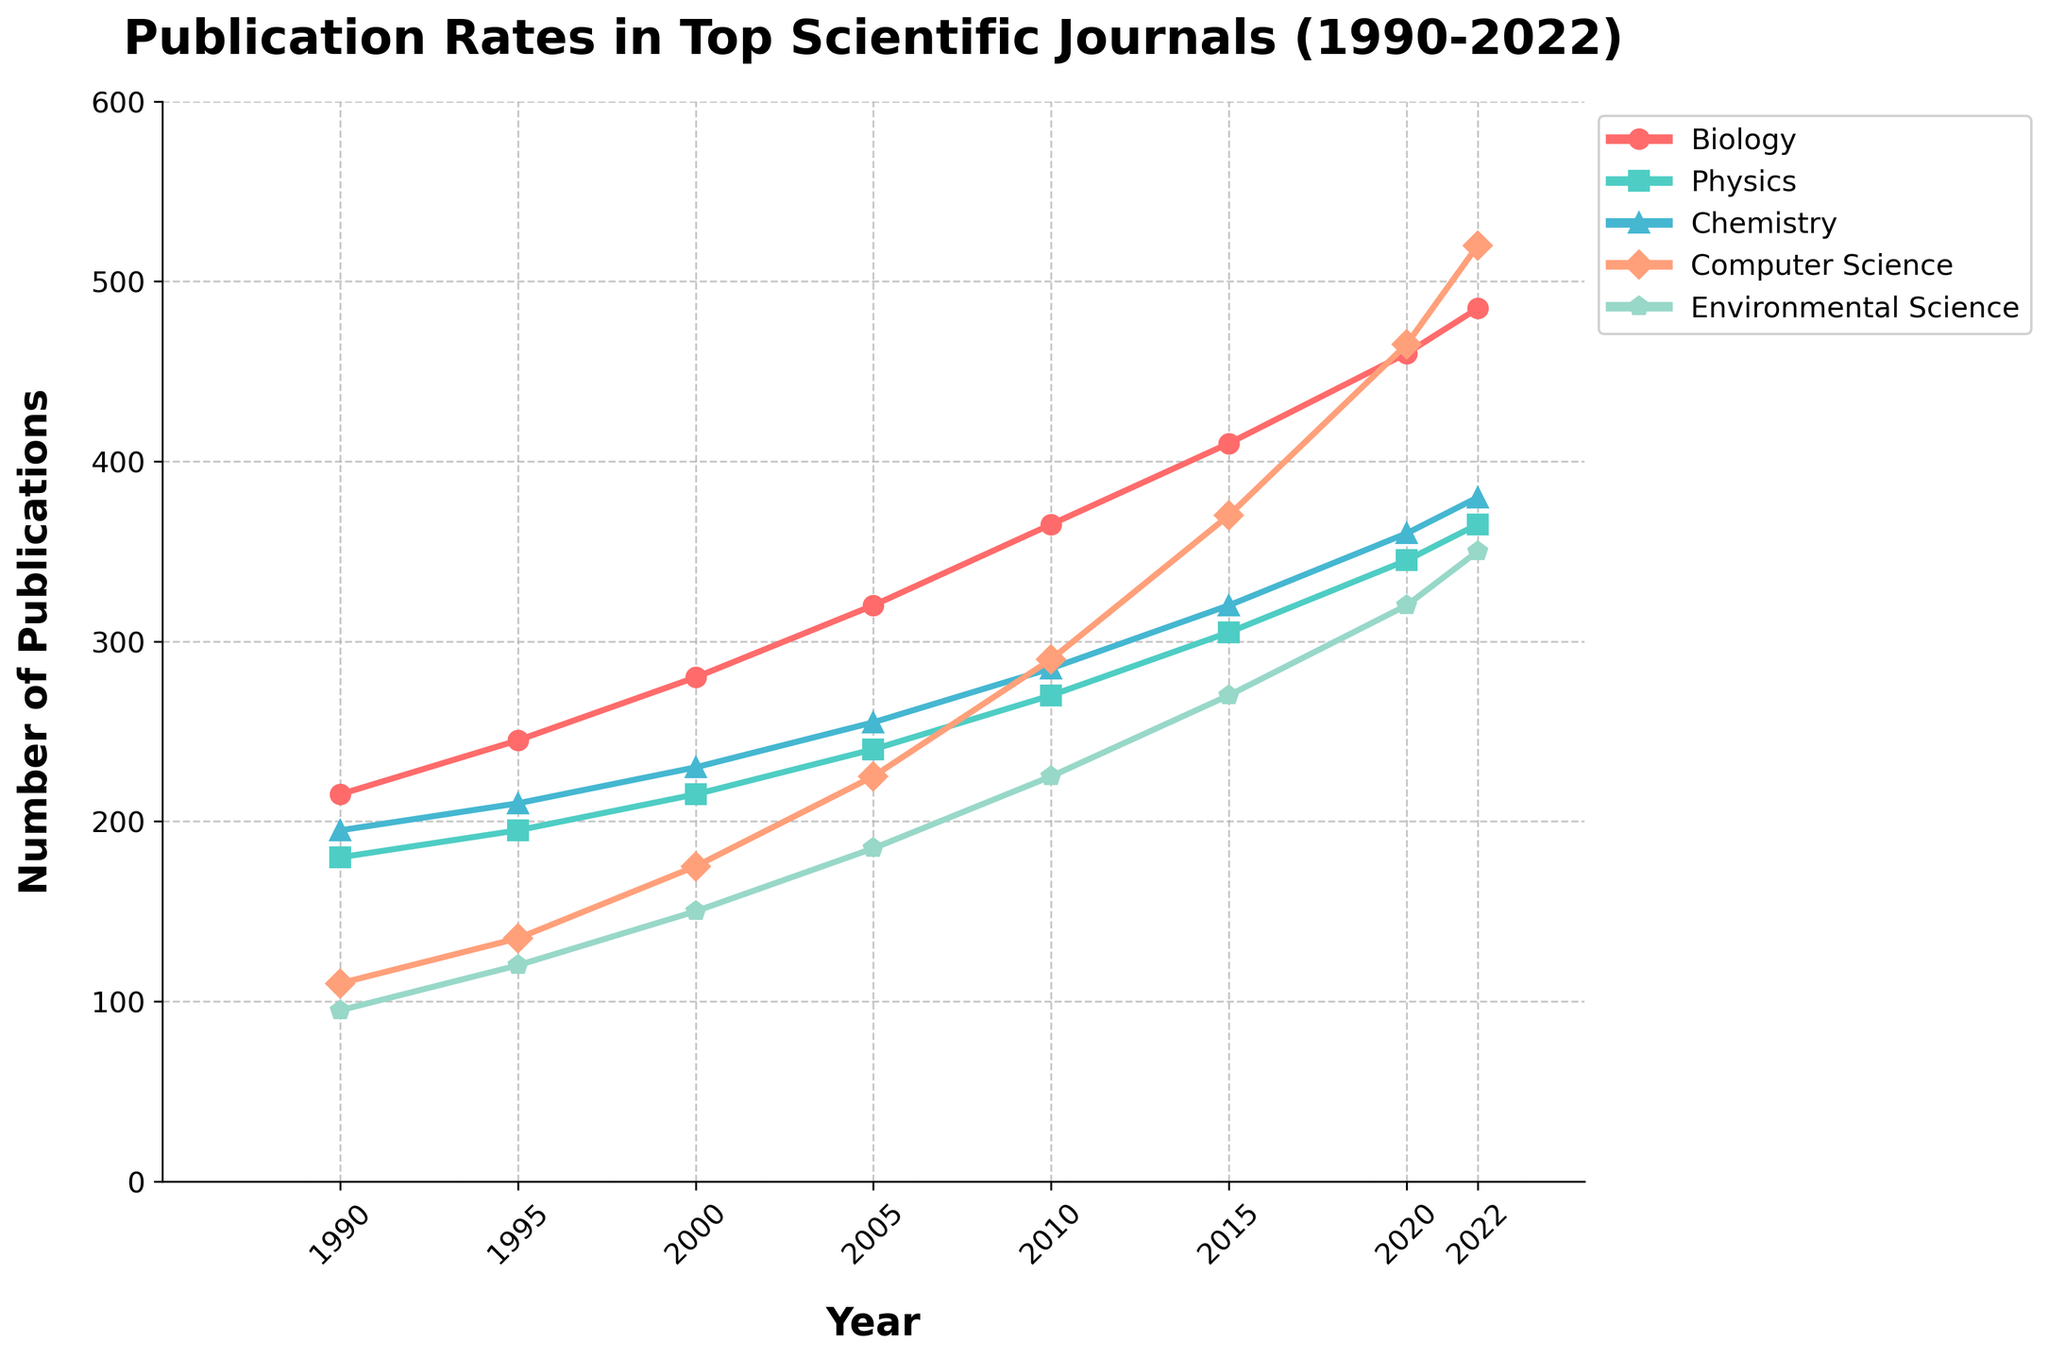What field had the highest publication rate in 2022? By looking at the end of the lines in 2022, Computer Science has the highest position, indicating the highest publication rate.
Answer: Computer Science Which field saw the largest increase in publications from 1990 to 2022? Calculate the difference in publication rates for all fields between 1990 and 2022. The differences are: 
- Biology: 485 - 215 = 270 
- Physics: 365 - 180 = 185 
- Chemistry: 380 - 195 = 185 
- Computer Science: 520 - 110 = 410 
- Environmental Science: 350 - 95 = 255 
Computer Science has the largest increase.
Answer: Computer Science How did the publication rate for Environmental Science change between 2000 and 2015? Check the publication rates for Environmental Science in 2000 and 2015, which are 150 and 270 respectively. The change is calculated as 270 - 150 = 120.
Answer: Increased by 120 What is the average publication rate for Physics over the years? Publication rates for Physics over the years are: 180, 195, 215, 240, 270, 305, 345, 365. To find the average, sum these values and divide by the number of values: (180 + 195 + 215 + 240 + 270 + 305 + 345 + 365) / 8 = 2400 / 8.
Answer: 300 Which year had the smallest publication rate for any field? Compare the lowest points of each line. The smallest value is 95 for Environmental Science in 1990.
Answer: 1990 In which period did Biology see the fastest growth in publication rates? Check intervals between years for Biology. The largest growth is between any two consecutive data points (difference): 
- 1990-1995: 245 - 215 = 30 
- 1995-2000: 280 - 245 = 35 
- 2000-2005: 320 - 280 = 40 
- 2005-2010: 365 - 320 = 45 
- 2010-2015: 410 - 365 = 45 
- 2015-2020: 460 - 410 = 50 
- 2020-2022: 485 - 460 = 25 
The fastest growth is between 2015 and 2020.
Answer: 2015-2020 Which two fields had similar publication rates in 2010? Look at the data points for each field in 2010: 
- Biology (365) 
- Physics (270) 
- Chemistry (285) 
- Computer Science (290) 
- Environmental Science (225) 
Physics and Chemistry have similar publication rates, as 270 and 285 are closest.
Answer: Physics and Chemistry By how much did Computer Science outperform Chemistry in 2022? Compare the publication rates for Computer Science and Chemistry in 2022: Computer Science (520) - Chemistry (380) = 140.
Answer: 140 